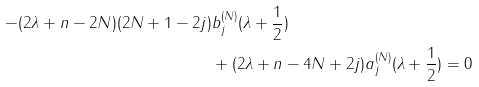<formula> <loc_0><loc_0><loc_500><loc_500>- ( 2 \lambda + n - 2 N ) ( 2 N + 1 - 2 j ) & b _ { j } ^ { ( N ) } ( \lambda + \frac { 1 } { 2 } ) \\ & + ( 2 \lambda + n - 4 N + 2 j ) a _ { j } ^ { ( N ) } ( \lambda + \frac { 1 } { 2 } ) = 0</formula> 